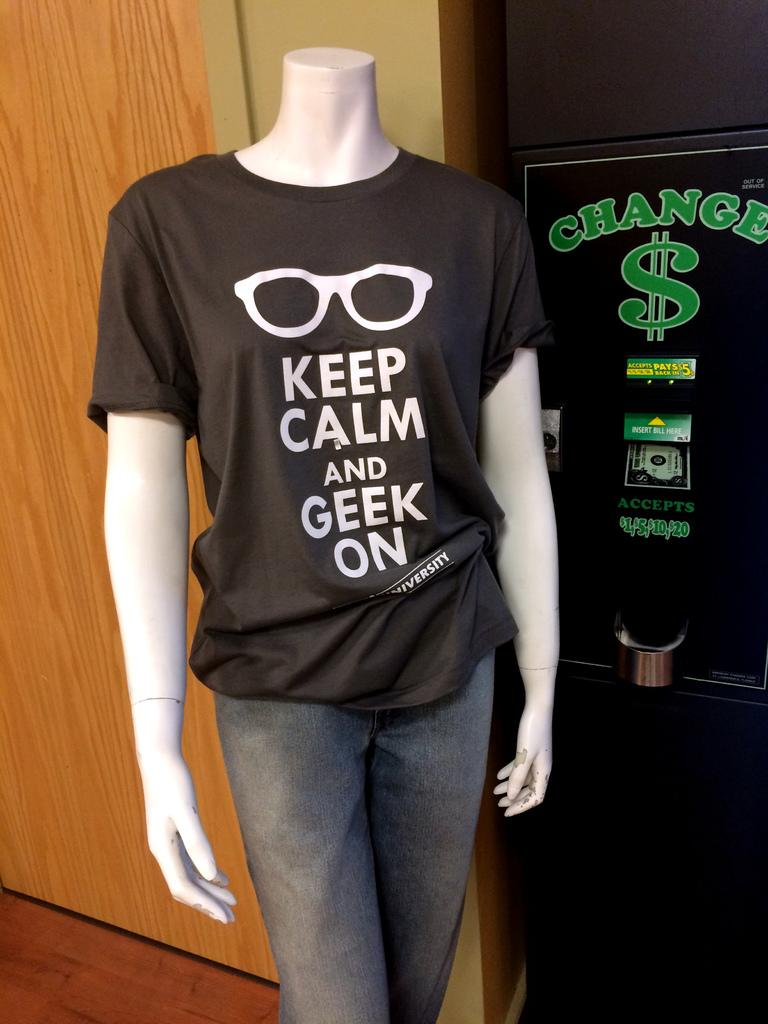<image>
Relay a brief, clear account of the picture shown. A manikin wearing a black shirt with sunglasses on it saying "Keep Calm and Geek on" also wearing gray sweat pant standing in front a change machine 